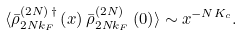<formula> <loc_0><loc_0><loc_500><loc_500>\langle { \bar { \rho } } ^ { ( 2 N ) \, \dagger } _ { 2 N k _ { F } } \left ( x \right ) { \bar { \rho } } ^ { ( 2 N ) } _ { 2 N k _ { F } } \left ( 0 \right ) \rangle \sim x ^ { - N K _ { c } } .</formula> 